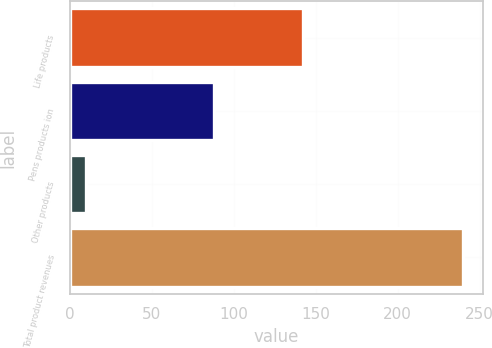Convert chart. <chart><loc_0><loc_0><loc_500><loc_500><bar_chart><fcel>Life products<fcel>Pens products ion<fcel>Other products<fcel>Total product revenues<nl><fcel>142<fcel>88<fcel>10<fcel>240<nl></chart> 